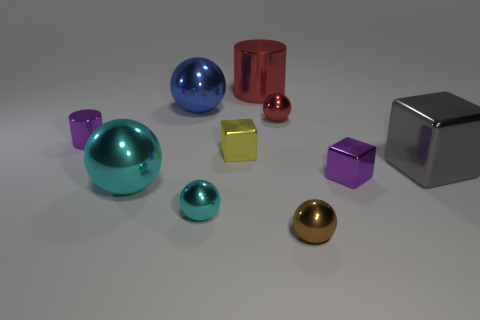What is the size of the purple block?
Keep it short and to the point. Small. What number of other objects are the same color as the small cylinder?
Your answer should be very brief. 1. What color is the tiny sphere that is behind the brown ball and to the right of the large shiny cylinder?
Your answer should be very brief. Red. How many gray blocks are there?
Provide a succinct answer. 1. Is the brown sphere made of the same material as the small purple cylinder?
Your answer should be compact. Yes. There is a small purple metallic object that is behind the large cube that is on the right side of the metallic block that is behind the large gray metal cube; what shape is it?
Make the answer very short. Cylinder. Is the material of the cylinder that is behind the purple cylinder the same as the purple object in front of the purple metal cylinder?
Your answer should be very brief. Yes. What material is the brown ball?
Provide a short and direct response. Metal. How many purple things have the same shape as the small red shiny object?
Offer a terse response. 0. There is a ball that is the same color as the big shiny cylinder; what material is it?
Your answer should be compact. Metal. 